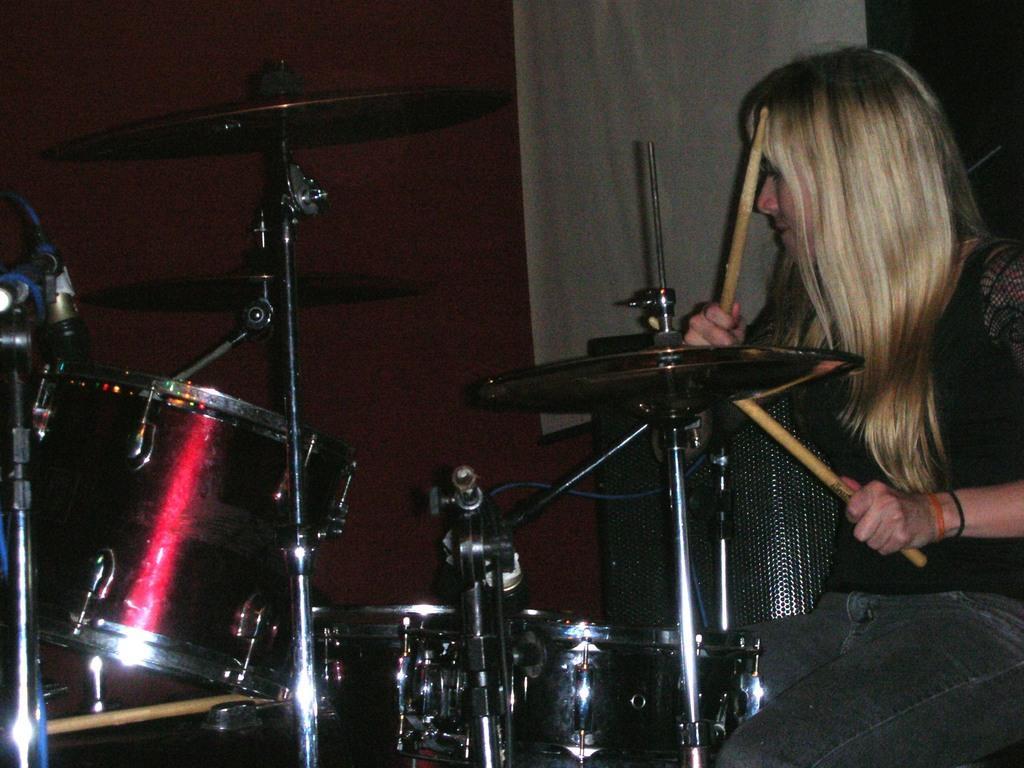Describe this image in one or two sentences. On the right side of the image there is a woman sitting facing towards left side and playing the drums. In the background there is a white color curtain and a wooden plank in the dark. 